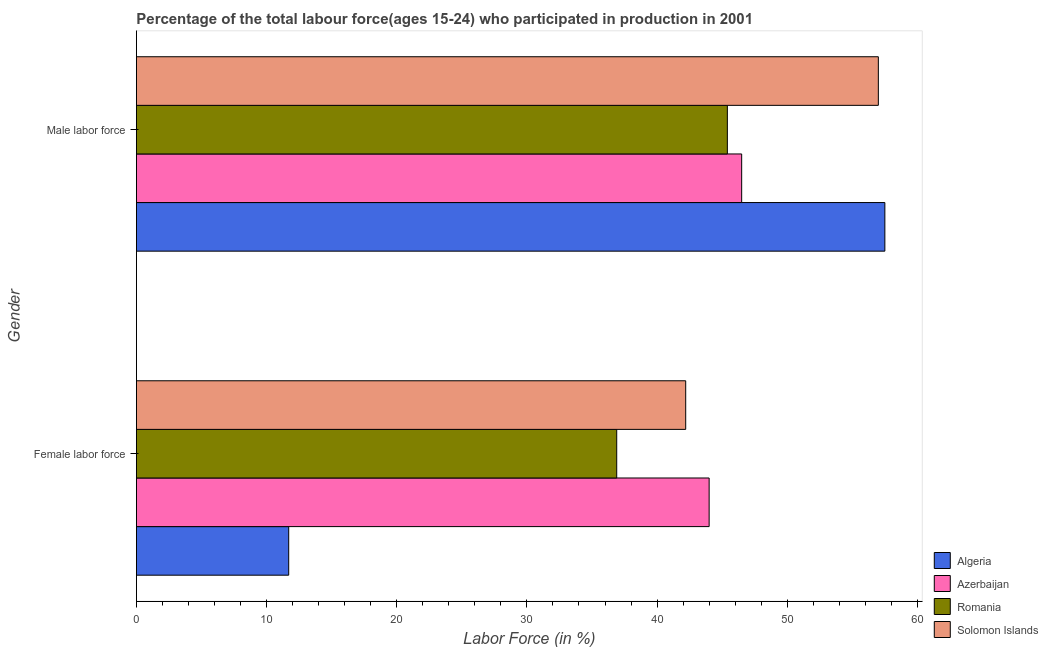Are the number of bars per tick equal to the number of legend labels?
Offer a terse response. Yes. Are the number of bars on each tick of the Y-axis equal?
Give a very brief answer. Yes. How many bars are there on the 1st tick from the top?
Your answer should be compact. 4. What is the label of the 1st group of bars from the top?
Your answer should be compact. Male labor force. What is the percentage of female labor force in Romania?
Offer a terse response. 36.9. Across all countries, what is the minimum percentage of female labor force?
Your answer should be very brief. 11.7. In which country was the percentage of male labour force maximum?
Ensure brevity in your answer.  Algeria. In which country was the percentage of female labor force minimum?
Provide a short and direct response. Algeria. What is the total percentage of male labour force in the graph?
Offer a terse response. 206.4. What is the difference between the percentage of female labor force in Romania and that in Azerbaijan?
Make the answer very short. -7.1. What is the difference between the percentage of male labour force in Algeria and the percentage of female labor force in Solomon Islands?
Your answer should be very brief. 15.3. What is the average percentage of female labor force per country?
Your answer should be very brief. 33.7. What is the difference between the percentage of female labor force and percentage of male labour force in Solomon Islands?
Provide a short and direct response. -14.8. In how many countries, is the percentage of male labour force greater than 4 %?
Keep it short and to the point. 4. What is the ratio of the percentage of male labour force in Azerbaijan to that in Romania?
Provide a short and direct response. 1.02. Is the percentage of female labor force in Azerbaijan less than that in Solomon Islands?
Offer a terse response. No. In how many countries, is the percentage of female labor force greater than the average percentage of female labor force taken over all countries?
Provide a succinct answer. 3. What does the 3rd bar from the top in Female labor force represents?
Make the answer very short. Azerbaijan. What does the 3rd bar from the bottom in Male labor force represents?
Provide a succinct answer. Romania. How many countries are there in the graph?
Provide a short and direct response. 4. What is the difference between two consecutive major ticks on the X-axis?
Offer a terse response. 10. How are the legend labels stacked?
Provide a succinct answer. Vertical. What is the title of the graph?
Provide a short and direct response. Percentage of the total labour force(ages 15-24) who participated in production in 2001. What is the Labor Force (in %) of Algeria in Female labor force?
Ensure brevity in your answer.  11.7. What is the Labor Force (in %) of Azerbaijan in Female labor force?
Offer a terse response. 44. What is the Labor Force (in %) of Romania in Female labor force?
Give a very brief answer. 36.9. What is the Labor Force (in %) in Solomon Islands in Female labor force?
Your answer should be compact. 42.2. What is the Labor Force (in %) of Algeria in Male labor force?
Make the answer very short. 57.5. What is the Labor Force (in %) in Azerbaijan in Male labor force?
Provide a succinct answer. 46.5. What is the Labor Force (in %) in Romania in Male labor force?
Provide a short and direct response. 45.4. What is the Labor Force (in %) in Solomon Islands in Male labor force?
Offer a terse response. 57. Across all Gender, what is the maximum Labor Force (in %) of Algeria?
Offer a terse response. 57.5. Across all Gender, what is the maximum Labor Force (in %) in Azerbaijan?
Make the answer very short. 46.5. Across all Gender, what is the maximum Labor Force (in %) of Romania?
Your answer should be compact. 45.4. Across all Gender, what is the minimum Labor Force (in %) of Algeria?
Ensure brevity in your answer.  11.7. Across all Gender, what is the minimum Labor Force (in %) in Azerbaijan?
Ensure brevity in your answer.  44. Across all Gender, what is the minimum Labor Force (in %) in Romania?
Keep it short and to the point. 36.9. Across all Gender, what is the minimum Labor Force (in %) in Solomon Islands?
Provide a short and direct response. 42.2. What is the total Labor Force (in %) in Algeria in the graph?
Offer a terse response. 69.2. What is the total Labor Force (in %) of Azerbaijan in the graph?
Provide a succinct answer. 90.5. What is the total Labor Force (in %) of Romania in the graph?
Provide a succinct answer. 82.3. What is the total Labor Force (in %) in Solomon Islands in the graph?
Your answer should be very brief. 99.2. What is the difference between the Labor Force (in %) of Algeria in Female labor force and that in Male labor force?
Give a very brief answer. -45.8. What is the difference between the Labor Force (in %) of Solomon Islands in Female labor force and that in Male labor force?
Give a very brief answer. -14.8. What is the difference between the Labor Force (in %) in Algeria in Female labor force and the Labor Force (in %) in Azerbaijan in Male labor force?
Your answer should be compact. -34.8. What is the difference between the Labor Force (in %) in Algeria in Female labor force and the Labor Force (in %) in Romania in Male labor force?
Your answer should be very brief. -33.7. What is the difference between the Labor Force (in %) of Algeria in Female labor force and the Labor Force (in %) of Solomon Islands in Male labor force?
Keep it short and to the point. -45.3. What is the difference between the Labor Force (in %) in Azerbaijan in Female labor force and the Labor Force (in %) in Romania in Male labor force?
Provide a succinct answer. -1.4. What is the difference between the Labor Force (in %) of Azerbaijan in Female labor force and the Labor Force (in %) of Solomon Islands in Male labor force?
Provide a short and direct response. -13. What is the difference between the Labor Force (in %) of Romania in Female labor force and the Labor Force (in %) of Solomon Islands in Male labor force?
Keep it short and to the point. -20.1. What is the average Labor Force (in %) of Algeria per Gender?
Provide a short and direct response. 34.6. What is the average Labor Force (in %) in Azerbaijan per Gender?
Your answer should be compact. 45.25. What is the average Labor Force (in %) in Romania per Gender?
Keep it short and to the point. 41.15. What is the average Labor Force (in %) in Solomon Islands per Gender?
Ensure brevity in your answer.  49.6. What is the difference between the Labor Force (in %) of Algeria and Labor Force (in %) of Azerbaijan in Female labor force?
Your answer should be very brief. -32.3. What is the difference between the Labor Force (in %) in Algeria and Labor Force (in %) in Romania in Female labor force?
Provide a succinct answer. -25.2. What is the difference between the Labor Force (in %) of Algeria and Labor Force (in %) of Solomon Islands in Female labor force?
Ensure brevity in your answer.  -30.5. What is the difference between the Labor Force (in %) of Azerbaijan and Labor Force (in %) of Romania in Female labor force?
Give a very brief answer. 7.1. What is the difference between the Labor Force (in %) of Algeria and Labor Force (in %) of Azerbaijan in Male labor force?
Your response must be concise. 11. What is the difference between the Labor Force (in %) in Algeria and Labor Force (in %) in Romania in Male labor force?
Your response must be concise. 12.1. What is the ratio of the Labor Force (in %) in Algeria in Female labor force to that in Male labor force?
Provide a short and direct response. 0.2. What is the ratio of the Labor Force (in %) in Azerbaijan in Female labor force to that in Male labor force?
Your answer should be compact. 0.95. What is the ratio of the Labor Force (in %) of Romania in Female labor force to that in Male labor force?
Make the answer very short. 0.81. What is the ratio of the Labor Force (in %) of Solomon Islands in Female labor force to that in Male labor force?
Keep it short and to the point. 0.74. What is the difference between the highest and the second highest Labor Force (in %) of Algeria?
Your answer should be very brief. 45.8. What is the difference between the highest and the second highest Labor Force (in %) in Azerbaijan?
Your response must be concise. 2.5. What is the difference between the highest and the second highest Labor Force (in %) of Romania?
Offer a very short reply. 8.5. What is the difference between the highest and the lowest Labor Force (in %) in Algeria?
Your answer should be compact. 45.8. What is the difference between the highest and the lowest Labor Force (in %) of Azerbaijan?
Make the answer very short. 2.5. What is the difference between the highest and the lowest Labor Force (in %) in Romania?
Give a very brief answer. 8.5. What is the difference between the highest and the lowest Labor Force (in %) in Solomon Islands?
Ensure brevity in your answer.  14.8. 